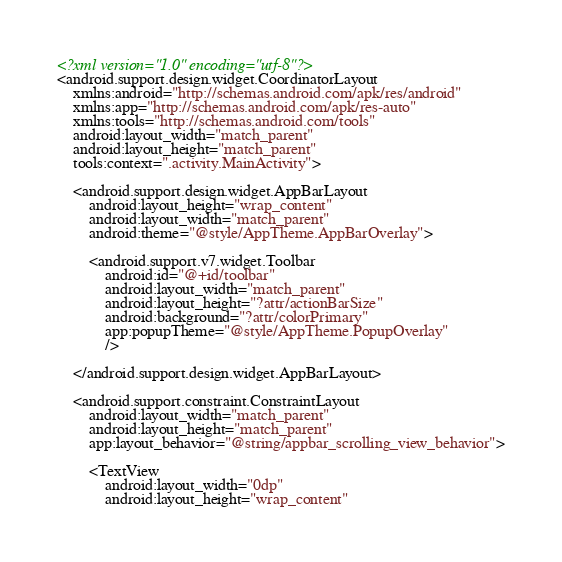<code> <loc_0><loc_0><loc_500><loc_500><_XML_><?xml version="1.0" encoding="utf-8"?>
<android.support.design.widget.CoordinatorLayout
    xmlns:android="http://schemas.android.com/apk/res/android"
    xmlns:app="http://schemas.android.com/apk/res-auto"
    xmlns:tools="http://schemas.android.com/tools"
    android:layout_width="match_parent"
    android:layout_height="match_parent"
    tools:context=".activity.MainActivity">

    <android.support.design.widget.AppBarLayout
        android:layout_height="wrap_content"
        android:layout_width="match_parent"
        android:theme="@style/AppTheme.AppBarOverlay">

        <android.support.v7.widget.Toolbar
            android:id="@+id/toolbar"
            android:layout_width="match_parent"
            android:layout_height="?attr/actionBarSize"
            android:background="?attr/colorPrimary"
            app:popupTheme="@style/AppTheme.PopupOverlay"
            />

    </android.support.design.widget.AppBarLayout>

    <android.support.constraint.ConstraintLayout
        android:layout_width="match_parent"
        android:layout_height="match_parent"
        app:layout_behavior="@string/appbar_scrolling_view_behavior">

        <TextView
            android:layout_width="0dp"
            android:layout_height="wrap_content"</code> 